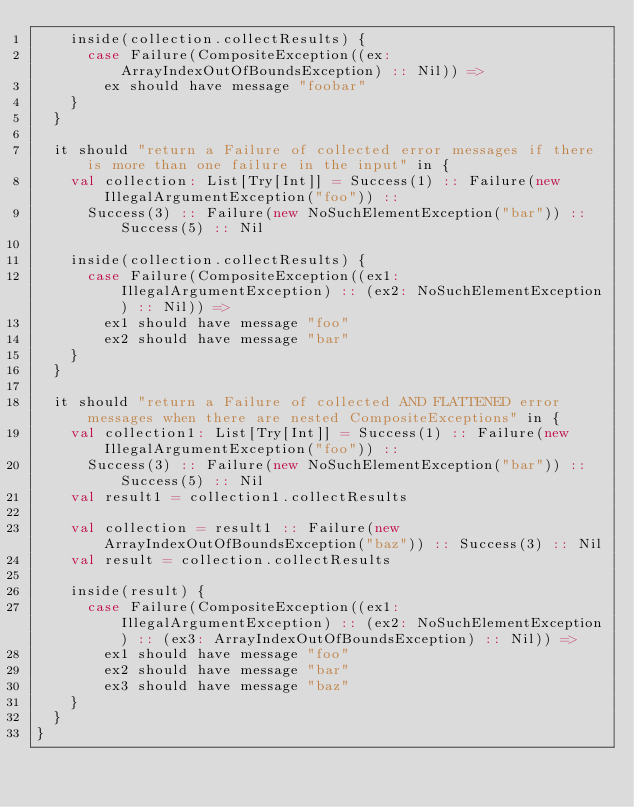Convert code to text. <code><loc_0><loc_0><loc_500><loc_500><_Scala_>    inside(collection.collectResults) {
      case Failure(CompositeException((ex: ArrayIndexOutOfBoundsException) :: Nil)) =>
        ex should have message "foobar"
    }
  }

  it should "return a Failure of collected error messages if there is more than one failure in the input" in {
    val collection: List[Try[Int]] = Success(1) :: Failure(new IllegalArgumentException("foo")) ::
      Success(3) :: Failure(new NoSuchElementException("bar")) :: Success(5) :: Nil

    inside(collection.collectResults) {
      case Failure(CompositeException((ex1: IllegalArgumentException) :: (ex2: NoSuchElementException) :: Nil)) =>
        ex1 should have message "foo"
        ex2 should have message "bar"
    }
  }

  it should "return a Failure of collected AND FLATTENED error messages when there are nested CompositeExceptions" in {
    val collection1: List[Try[Int]] = Success(1) :: Failure(new IllegalArgumentException("foo")) ::
      Success(3) :: Failure(new NoSuchElementException("bar")) :: Success(5) :: Nil
    val result1 = collection1.collectResults

    val collection = result1 :: Failure(new ArrayIndexOutOfBoundsException("baz")) :: Success(3) :: Nil
    val result = collection.collectResults

    inside(result) {
      case Failure(CompositeException((ex1: IllegalArgumentException) :: (ex2: NoSuchElementException) :: (ex3: ArrayIndexOutOfBoundsException) :: Nil)) =>
        ex1 should have message "foo"
        ex2 should have message "bar"
        ex3 should have message "baz"
    }
  }
}
</code> 